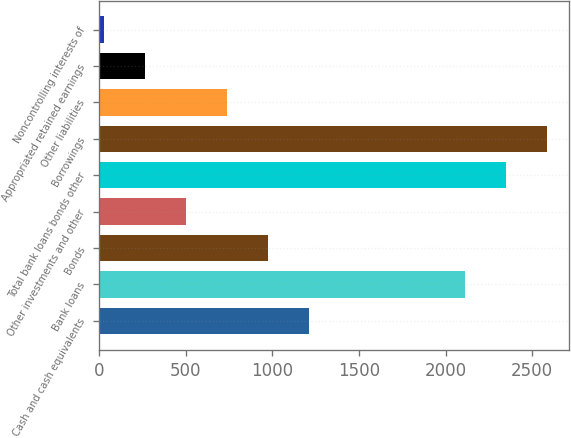<chart> <loc_0><loc_0><loc_500><loc_500><bar_chart><fcel>Cash and cash equivalents<fcel>Bank loans<fcel>Bonds<fcel>Other investments and other<fcel>Total bank loans bonds other<fcel>Borrowings<fcel>Other liabilities<fcel>Appropriated retained earnings<fcel>Noncontrolling interests of<nl><fcel>1214.5<fcel>2110<fcel>977<fcel>502<fcel>2347.5<fcel>2585<fcel>739.5<fcel>264.5<fcel>27<nl></chart> 